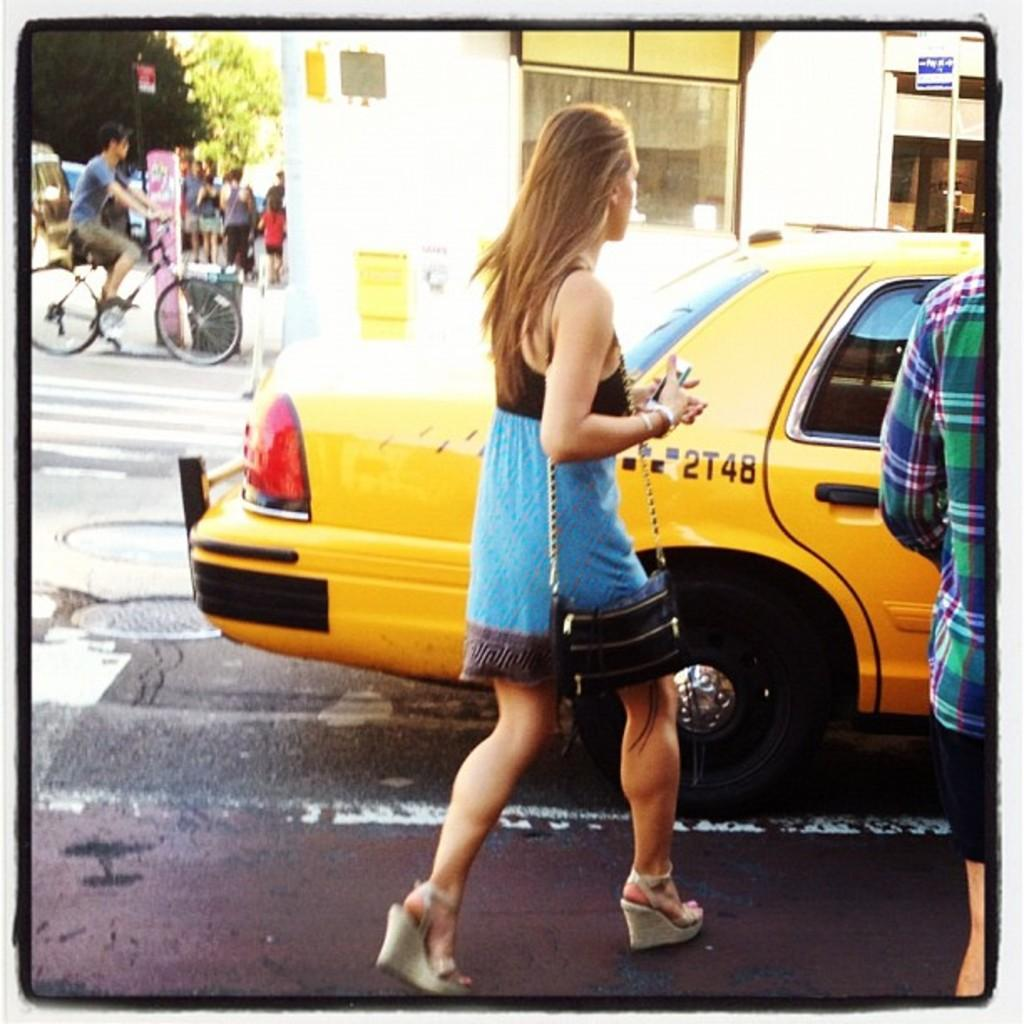Provide a one-sentence caption for the provided image. A yellow cab has the identification number 2T48 on its side. 